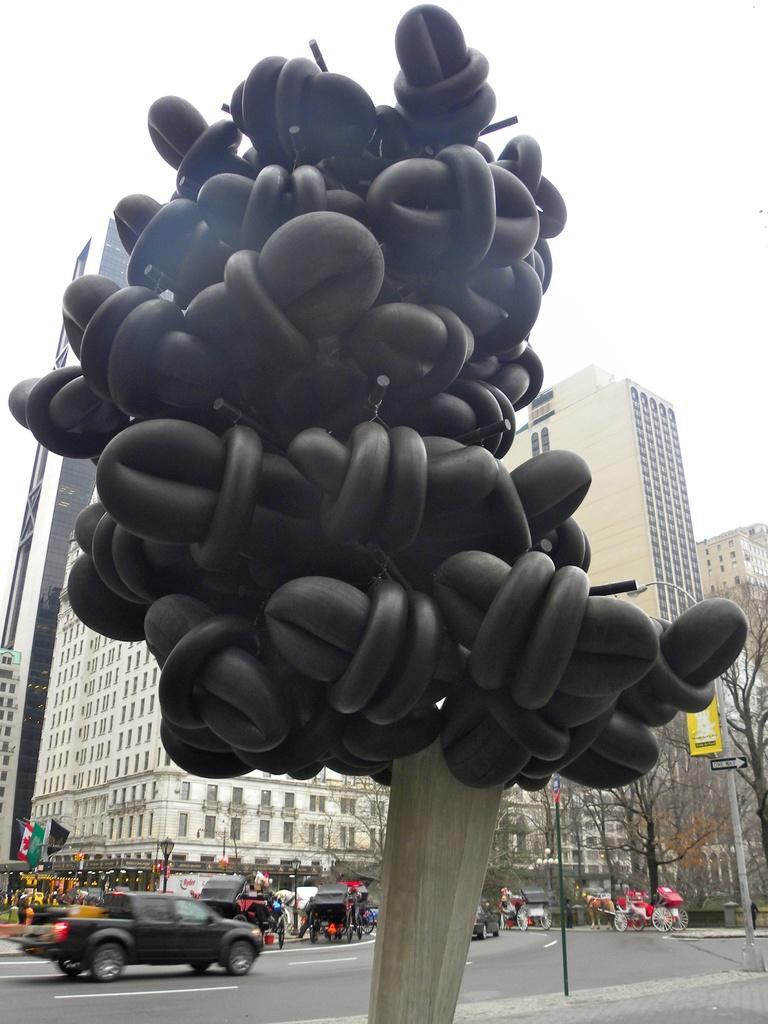Can you describe this image briefly? In the center of the image we can see a sculpture. At the bottom there are vehicles on the road. In the background there are buildings, trees, poles, flags, boards, people and sky. 